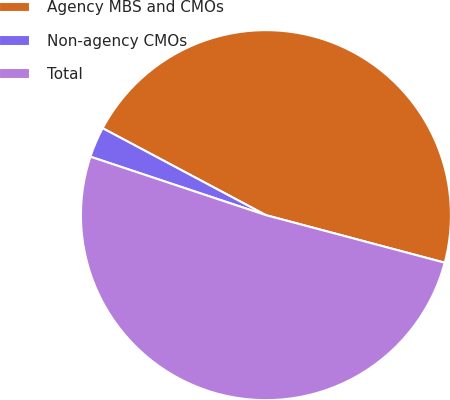<chart> <loc_0><loc_0><loc_500><loc_500><pie_chart><fcel>Agency MBS and CMOs<fcel>Non-agency CMOs<fcel>Total<nl><fcel>46.35%<fcel>2.67%<fcel>50.98%<nl></chart> 